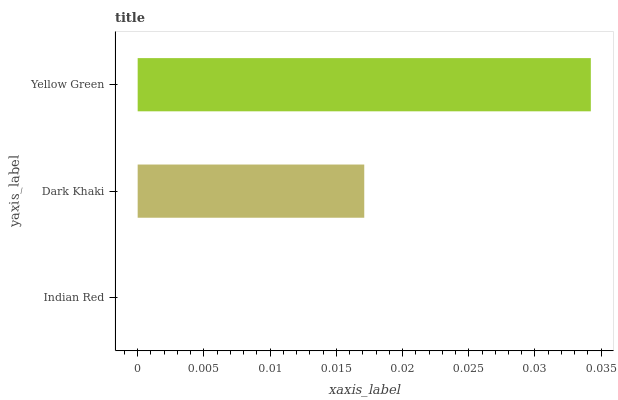Is Indian Red the minimum?
Answer yes or no. Yes. Is Yellow Green the maximum?
Answer yes or no. Yes. Is Dark Khaki the minimum?
Answer yes or no. No. Is Dark Khaki the maximum?
Answer yes or no. No. Is Dark Khaki greater than Indian Red?
Answer yes or no. Yes. Is Indian Red less than Dark Khaki?
Answer yes or no. Yes. Is Indian Red greater than Dark Khaki?
Answer yes or no. No. Is Dark Khaki less than Indian Red?
Answer yes or no. No. Is Dark Khaki the high median?
Answer yes or no. Yes. Is Dark Khaki the low median?
Answer yes or no. Yes. Is Indian Red the high median?
Answer yes or no. No. Is Yellow Green the low median?
Answer yes or no. No. 